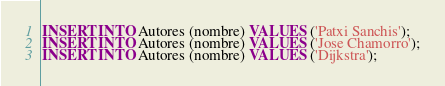Convert code to text. <code><loc_0><loc_0><loc_500><loc_500><_SQL_>
INSERT INTO Autores (nombre) VALUES ('Patxi Sanchis');
INSERT INTO Autores (nombre) VALUES ('Jose Chamorro');
INSERT INTO Autores (nombre) VALUES ('Dijkstra');
</code> 